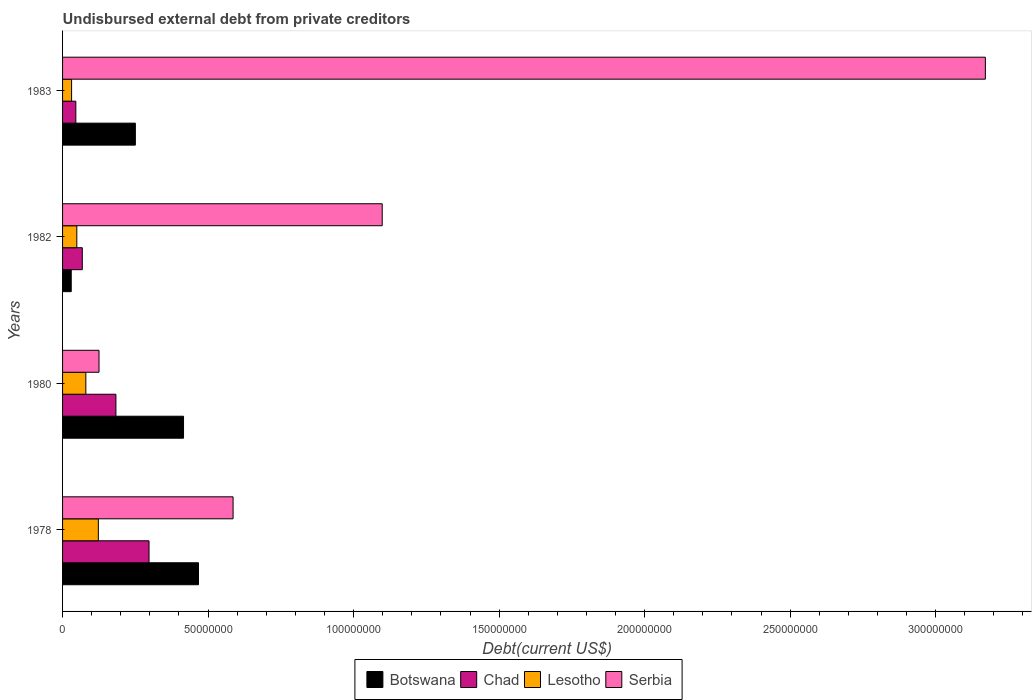How many different coloured bars are there?
Your response must be concise. 4. How many groups of bars are there?
Provide a short and direct response. 4. Are the number of bars on each tick of the Y-axis equal?
Offer a terse response. Yes. How many bars are there on the 3rd tick from the top?
Ensure brevity in your answer.  4. How many bars are there on the 4th tick from the bottom?
Offer a very short reply. 4. What is the label of the 4th group of bars from the top?
Make the answer very short. 1978. What is the total debt in Botswana in 1983?
Make the answer very short. 2.50e+07. Across all years, what is the maximum total debt in Botswana?
Your response must be concise. 4.67e+07. Across all years, what is the minimum total debt in Botswana?
Provide a succinct answer. 2.98e+06. In which year was the total debt in Botswana maximum?
Provide a succinct answer. 1978. In which year was the total debt in Chad minimum?
Give a very brief answer. 1983. What is the total total debt in Botswana in the graph?
Provide a short and direct response. 1.16e+08. What is the difference between the total debt in Botswana in 1978 and that in 1980?
Keep it short and to the point. 5.14e+06. What is the difference between the total debt in Lesotho in 1980 and the total debt in Botswana in 1982?
Provide a succinct answer. 5.02e+06. What is the average total debt in Botswana per year?
Your answer should be compact. 2.91e+07. In the year 1983, what is the difference between the total debt in Lesotho and total debt in Botswana?
Your answer should be compact. -2.19e+07. What is the ratio of the total debt in Chad in 1978 to that in 1983?
Your response must be concise. 6.52. Is the total debt in Chad in 1980 less than that in 1982?
Make the answer very short. No. Is the difference between the total debt in Lesotho in 1978 and 1980 greater than the difference between the total debt in Botswana in 1978 and 1980?
Offer a very short reply. No. What is the difference between the highest and the second highest total debt in Chad?
Your answer should be compact. 1.14e+07. What is the difference between the highest and the lowest total debt in Serbia?
Make the answer very short. 3.05e+08. In how many years, is the total debt in Chad greater than the average total debt in Chad taken over all years?
Your response must be concise. 2. What does the 4th bar from the top in 1980 represents?
Your answer should be very brief. Botswana. What does the 2nd bar from the bottom in 1983 represents?
Your response must be concise. Chad. Are all the bars in the graph horizontal?
Offer a very short reply. Yes. Are the values on the major ticks of X-axis written in scientific E-notation?
Give a very brief answer. No. How are the legend labels stacked?
Provide a short and direct response. Horizontal. What is the title of the graph?
Offer a terse response. Undisbursed external debt from private creditors. Does "Barbados" appear as one of the legend labels in the graph?
Give a very brief answer. No. What is the label or title of the X-axis?
Your answer should be very brief. Debt(current US$). What is the Debt(current US$) in Botswana in 1978?
Your answer should be very brief. 4.67e+07. What is the Debt(current US$) of Chad in 1978?
Your answer should be very brief. 2.97e+07. What is the Debt(current US$) of Lesotho in 1978?
Give a very brief answer. 1.23e+07. What is the Debt(current US$) of Serbia in 1978?
Give a very brief answer. 5.86e+07. What is the Debt(current US$) in Botswana in 1980?
Keep it short and to the point. 4.16e+07. What is the Debt(current US$) of Chad in 1980?
Offer a terse response. 1.83e+07. What is the Debt(current US$) in Lesotho in 1980?
Provide a succinct answer. 8.00e+06. What is the Debt(current US$) in Serbia in 1980?
Make the answer very short. 1.25e+07. What is the Debt(current US$) of Botswana in 1982?
Offer a terse response. 2.98e+06. What is the Debt(current US$) of Chad in 1982?
Your answer should be compact. 6.78e+06. What is the Debt(current US$) in Lesotho in 1982?
Give a very brief answer. 4.89e+06. What is the Debt(current US$) of Serbia in 1982?
Your answer should be very brief. 1.10e+08. What is the Debt(current US$) of Botswana in 1983?
Provide a succinct answer. 2.50e+07. What is the Debt(current US$) of Chad in 1983?
Your response must be concise. 4.56e+06. What is the Debt(current US$) in Lesotho in 1983?
Provide a short and direct response. 3.10e+06. What is the Debt(current US$) in Serbia in 1983?
Make the answer very short. 3.17e+08. Across all years, what is the maximum Debt(current US$) of Botswana?
Keep it short and to the point. 4.67e+07. Across all years, what is the maximum Debt(current US$) in Chad?
Your answer should be compact. 2.97e+07. Across all years, what is the maximum Debt(current US$) in Lesotho?
Offer a very short reply. 1.23e+07. Across all years, what is the maximum Debt(current US$) of Serbia?
Offer a terse response. 3.17e+08. Across all years, what is the minimum Debt(current US$) in Botswana?
Keep it short and to the point. 2.98e+06. Across all years, what is the minimum Debt(current US$) in Chad?
Your response must be concise. 4.56e+06. Across all years, what is the minimum Debt(current US$) in Lesotho?
Keep it short and to the point. 3.10e+06. Across all years, what is the minimum Debt(current US$) in Serbia?
Your answer should be compact. 1.25e+07. What is the total Debt(current US$) in Botswana in the graph?
Your response must be concise. 1.16e+08. What is the total Debt(current US$) of Chad in the graph?
Your answer should be very brief. 5.94e+07. What is the total Debt(current US$) in Lesotho in the graph?
Your answer should be very brief. 2.83e+07. What is the total Debt(current US$) of Serbia in the graph?
Provide a short and direct response. 4.98e+08. What is the difference between the Debt(current US$) of Botswana in 1978 and that in 1980?
Your answer should be very brief. 5.14e+06. What is the difference between the Debt(current US$) in Chad in 1978 and that in 1980?
Offer a very short reply. 1.14e+07. What is the difference between the Debt(current US$) of Lesotho in 1978 and that in 1980?
Make the answer very short. 4.29e+06. What is the difference between the Debt(current US$) in Serbia in 1978 and that in 1980?
Provide a short and direct response. 4.61e+07. What is the difference between the Debt(current US$) of Botswana in 1978 and that in 1982?
Offer a very short reply. 4.37e+07. What is the difference between the Debt(current US$) in Chad in 1978 and that in 1982?
Your answer should be very brief. 2.29e+07. What is the difference between the Debt(current US$) in Lesotho in 1978 and that in 1982?
Your answer should be compact. 7.40e+06. What is the difference between the Debt(current US$) of Serbia in 1978 and that in 1982?
Make the answer very short. -5.12e+07. What is the difference between the Debt(current US$) of Botswana in 1978 and that in 1983?
Offer a very short reply. 2.17e+07. What is the difference between the Debt(current US$) in Chad in 1978 and that in 1983?
Your response must be concise. 2.52e+07. What is the difference between the Debt(current US$) in Lesotho in 1978 and that in 1983?
Provide a succinct answer. 9.19e+06. What is the difference between the Debt(current US$) in Serbia in 1978 and that in 1983?
Give a very brief answer. -2.58e+08. What is the difference between the Debt(current US$) of Botswana in 1980 and that in 1982?
Your answer should be compact. 3.86e+07. What is the difference between the Debt(current US$) of Chad in 1980 and that in 1982?
Provide a succinct answer. 1.16e+07. What is the difference between the Debt(current US$) in Lesotho in 1980 and that in 1982?
Provide a short and direct response. 3.11e+06. What is the difference between the Debt(current US$) of Serbia in 1980 and that in 1982?
Provide a succinct answer. -9.73e+07. What is the difference between the Debt(current US$) in Botswana in 1980 and that in 1983?
Offer a terse response. 1.66e+07. What is the difference between the Debt(current US$) of Chad in 1980 and that in 1983?
Ensure brevity in your answer.  1.38e+07. What is the difference between the Debt(current US$) of Lesotho in 1980 and that in 1983?
Provide a succinct answer. 4.90e+06. What is the difference between the Debt(current US$) of Serbia in 1980 and that in 1983?
Offer a very short reply. -3.05e+08. What is the difference between the Debt(current US$) of Botswana in 1982 and that in 1983?
Offer a terse response. -2.20e+07. What is the difference between the Debt(current US$) of Chad in 1982 and that in 1983?
Your answer should be compact. 2.22e+06. What is the difference between the Debt(current US$) in Lesotho in 1982 and that in 1983?
Make the answer very short. 1.79e+06. What is the difference between the Debt(current US$) of Serbia in 1982 and that in 1983?
Your answer should be very brief. -2.07e+08. What is the difference between the Debt(current US$) of Botswana in 1978 and the Debt(current US$) of Chad in 1980?
Offer a terse response. 2.84e+07. What is the difference between the Debt(current US$) of Botswana in 1978 and the Debt(current US$) of Lesotho in 1980?
Keep it short and to the point. 3.87e+07. What is the difference between the Debt(current US$) of Botswana in 1978 and the Debt(current US$) of Serbia in 1980?
Offer a very short reply. 3.42e+07. What is the difference between the Debt(current US$) of Chad in 1978 and the Debt(current US$) of Lesotho in 1980?
Make the answer very short. 2.17e+07. What is the difference between the Debt(current US$) of Chad in 1978 and the Debt(current US$) of Serbia in 1980?
Ensure brevity in your answer.  1.72e+07. What is the difference between the Debt(current US$) in Lesotho in 1978 and the Debt(current US$) in Serbia in 1980?
Provide a succinct answer. -2.31e+05. What is the difference between the Debt(current US$) in Botswana in 1978 and the Debt(current US$) in Chad in 1982?
Your answer should be compact. 3.99e+07. What is the difference between the Debt(current US$) in Botswana in 1978 and the Debt(current US$) in Lesotho in 1982?
Ensure brevity in your answer.  4.18e+07. What is the difference between the Debt(current US$) of Botswana in 1978 and the Debt(current US$) of Serbia in 1982?
Offer a terse response. -6.31e+07. What is the difference between the Debt(current US$) in Chad in 1978 and the Debt(current US$) in Lesotho in 1982?
Ensure brevity in your answer.  2.48e+07. What is the difference between the Debt(current US$) in Chad in 1978 and the Debt(current US$) in Serbia in 1982?
Provide a short and direct response. -8.01e+07. What is the difference between the Debt(current US$) in Lesotho in 1978 and the Debt(current US$) in Serbia in 1982?
Your answer should be compact. -9.75e+07. What is the difference between the Debt(current US$) of Botswana in 1978 and the Debt(current US$) of Chad in 1983?
Provide a succinct answer. 4.21e+07. What is the difference between the Debt(current US$) in Botswana in 1978 and the Debt(current US$) in Lesotho in 1983?
Provide a succinct answer. 4.36e+07. What is the difference between the Debt(current US$) in Botswana in 1978 and the Debt(current US$) in Serbia in 1983?
Offer a very short reply. -2.70e+08. What is the difference between the Debt(current US$) of Chad in 1978 and the Debt(current US$) of Lesotho in 1983?
Offer a terse response. 2.66e+07. What is the difference between the Debt(current US$) of Chad in 1978 and the Debt(current US$) of Serbia in 1983?
Make the answer very short. -2.87e+08. What is the difference between the Debt(current US$) in Lesotho in 1978 and the Debt(current US$) in Serbia in 1983?
Provide a short and direct response. -3.05e+08. What is the difference between the Debt(current US$) in Botswana in 1980 and the Debt(current US$) in Chad in 1982?
Your answer should be compact. 3.48e+07. What is the difference between the Debt(current US$) in Botswana in 1980 and the Debt(current US$) in Lesotho in 1982?
Give a very brief answer. 3.67e+07. What is the difference between the Debt(current US$) in Botswana in 1980 and the Debt(current US$) in Serbia in 1982?
Ensure brevity in your answer.  -6.83e+07. What is the difference between the Debt(current US$) of Chad in 1980 and the Debt(current US$) of Lesotho in 1982?
Provide a short and direct response. 1.34e+07. What is the difference between the Debt(current US$) of Chad in 1980 and the Debt(current US$) of Serbia in 1982?
Ensure brevity in your answer.  -9.15e+07. What is the difference between the Debt(current US$) of Lesotho in 1980 and the Debt(current US$) of Serbia in 1982?
Your answer should be very brief. -1.02e+08. What is the difference between the Debt(current US$) in Botswana in 1980 and the Debt(current US$) in Chad in 1983?
Make the answer very short. 3.70e+07. What is the difference between the Debt(current US$) in Botswana in 1980 and the Debt(current US$) in Lesotho in 1983?
Your answer should be very brief. 3.85e+07. What is the difference between the Debt(current US$) of Botswana in 1980 and the Debt(current US$) of Serbia in 1983?
Keep it short and to the point. -2.76e+08. What is the difference between the Debt(current US$) in Chad in 1980 and the Debt(current US$) in Lesotho in 1983?
Offer a terse response. 1.52e+07. What is the difference between the Debt(current US$) of Chad in 1980 and the Debt(current US$) of Serbia in 1983?
Your answer should be very brief. -2.99e+08. What is the difference between the Debt(current US$) of Lesotho in 1980 and the Debt(current US$) of Serbia in 1983?
Your answer should be compact. -3.09e+08. What is the difference between the Debt(current US$) of Botswana in 1982 and the Debt(current US$) of Chad in 1983?
Offer a very short reply. -1.58e+06. What is the difference between the Debt(current US$) in Botswana in 1982 and the Debt(current US$) in Lesotho in 1983?
Ensure brevity in your answer.  -1.24e+05. What is the difference between the Debt(current US$) in Botswana in 1982 and the Debt(current US$) in Serbia in 1983?
Ensure brevity in your answer.  -3.14e+08. What is the difference between the Debt(current US$) in Chad in 1982 and the Debt(current US$) in Lesotho in 1983?
Your answer should be very brief. 3.68e+06. What is the difference between the Debt(current US$) in Chad in 1982 and the Debt(current US$) in Serbia in 1983?
Offer a very short reply. -3.10e+08. What is the difference between the Debt(current US$) in Lesotho in 1982 and the Debt(current US$) in Serbia in 1983?
Your response must be concise. -3.12e+08. What is the average Debt(current US$) of Botswana per year?
Ensure brevity in your answer.  2.91e+07. What is the average Debt(current US$) of Chad per year?
Offer a terse response. 1.48e+07. What is the average Debt(current US$) of Lesotho per year?
Your response must be concise. 7.07e+06. What is the average Debt(current US$) of Serbia per year?
Provide a succinct answer. 1.25e+08. In the year 1978, what is the difference between the Debt(current US$) of Botswana and Debt(current US$) of Chad?
Your answer should be very brief. 1.70e+07. In the year 1978, what is the difference between the Debt(current US$) in Botswana and Debt(current US$) in Lesotho?
Offer a very short reply. 3.44e+07. In the year 1978, what is the difference between the Debt(current US$) in Botswana and Debt(current US$) in Serbia?
Give a very brief answer. -1.19e+07. In the year 1978, what is the difference between the Debt(current US$) in Chad and Debt(current US$) in Lesotho?
Provide a short and direct response. 1.74e+07. In the year 1978, what is the difference between the Debt(current US$) in Chad and Debt(current US$) in Serbia?
Give a very brief answer. -2.89e+07. In the year 1978, what is the difference between the Debt(current US$) of Lesotho and Debt(current US$) of Serbia?
Provide a succinct answer. -4.63e+07. In the year 1980, what is the difference between the Debt(current US$) in Botswana and Debt(current US$) in Chad?
Your answer should be very brief. 2.32e+07. In the year 1980, what is the difference between the Debt(current US$) of Botswana and Debt(current US$) of Lesotho?
Offer a terse response. 3.36e+07. In the year 1980, what is the difference between the Debt(current US$) in Botswana and Debt(current US$) in Serbia?
Your answer should be compact. 2.90e+07. In the year 1980, what is the difference between the Debt(current US$) of Chad and Debt(current US$) of Lesotho?
Ensure brevity in your answer.  1.03e+07. In the year 1980, what is the difference between the Debt(current US$) in Chad and Debt(current US$) in Serbia?
Offer a very short reply. 5.81e+06. In the year 1980, what is the difference between the Debt(current US$) in Lesotho and Debt(current US$) in Serbia?
Provide a succinct answer. -4.52e+06. In the year 1982, what is the difference between the Debt(current US$) in Botswana and Debt(current US$) in Chad?
Offer a very short reply. -3.80e+06. In the year 1982, what is the difference between the Debt(current US$) of Botswana and Debt(current US$) of Lesotho?
Offer a terse response. -1.92e+06. In the year 1982, what is the difference between the Debt(current US$) in Botswana and Debt(current US$) in Serbia?
Offer a terse response. -1.07e+08. In the year 1982, what is the difference between the Debt(current US$) of Chad and Debt(current US$) of Lesotho?
Provide a succinct answer. 1.89e+06. In the year 1982, what is the difference between the Debt(current US$) in Chad and Debt(current US$) in Serbia?
Offer a very short reply. -1.03e+08. In the year 1982, what is the difference between the Debt(current US$) of Lesotho and Debt(current US$) of Serbia?
Your response must be concise. -1.05e+08. In the year 1983, what is the difference between the Debt(current US$) of Botswana and Debt(current US$) of Chad?
Keep it short and to the point. 2.05e+07. In the year 1983, what is the difference between the Debt(current US$) of Botswana and Debt(current US$) of Lesotho?
Provide a short and direct response. 2.19e+07. In the year 1983, what is the difference between the Debt(current US$) of Botswana and Debt(current US$) of Serbia?
Offer a very short reply. -2.92e+08. In the year 1983, what is the difference between the Debt(current US$) of Chad and Debt(current US$) of Lesotho?
Provide a succinct answer. 1.46e+06. In the year 1983, what is the difference between the Debt(current US$) of Chad and Debt(current US$) of Serbia?
Offer a terse response. -3.13e+08. In the year 1983, what is the difference between the Debt(current US$) of Lesotho and Debt(current US$) of Serbia?
Give a very brief answer. -3.14e+08. What is the ratio of the Debt(current US$) in Botswana in 1978 to that in 1980?
Your answer should be compact. 1.12. What is the ratio of the Debt(current US$) in Chad in 1978 to that in 1980?
Offer a very short reply. 1.62. What is the ratio of the Debt(current US$) of Lesotho in 1978 to that in 1980?
Offer a very short reply. 1.54. What is the ratio of the Debt(current US$) of Serbia in 1978 to that in 1980?
Your response must be concise. 4.68. What is the ratio of the Debt(current US$) in Botswana in 1978 to that in 1982?
Offer a very short reply. 15.69. What is the ratio of the Debt(current US$) in Chad in 1978 to that in 1982?
Your response must be concise. 4.38. What is the ratio of the Debt(current US$) of Lesotho in 1978 to that in 1982?
Offer a very short reply. 2.51. What is the ratio of the Debt(current US$) of Serbia in 1978 to that in 1982?
Ensure brevity in your answer.  0.53. What is the ratio of the Debt(current US$) in Botswana in 1978 to that in 1983?
Keep it short and to the point. 1.87. What is the ratio of the Debt(current US$) in Chad in 1978 to that in 1983?
Provide a succinct answer. 6.52. What is the ratio of the Debt(current US$) in Lesotho in 1978 to that in 1983?
Provide a succinct answer. 3.96. What is the ratio of the Debt(current US$) of Serbia in 1978 to that in 1983?
Your response must be concise. 0.18. What is the ratio of the Debt(current US$) of Botswana in 1980 to that in 1982?
Your response must be concise. 13.96. What is the ratio of the Debt(current US$) of Chad in 1980 to that in 1982?
Give a very brief answer. 2.7. What is the ratio of the Debt(current US$) of Lesotho in 1980 to that in 1982?
Provide a short and direct response. 1.64. What is the ratio of the Debt(current US$) in Serbia in 1980 to that in 1982?
Provide a succinct answer. 0.11. What is the ratio of the Debt(current US$) of Botswana in 1980 to that in 1983?
Your response must be concise. 1.66. What is the ratio of the Debt(current US$) of Chad in 1980 to that in 1983?
Your response must be concise. 4.02. What is the ratio of the Debt(current US$) in Lesotho in 1980 to that in 1983?
Offer a terse response. 2.58. What is the ratio of the Debt(current US$) in Serbia in 1980 to that in 1983?
Provide a short and direct response. 0.04. What is the ratio of the Debt(current US$) in Botswana in 1982 to that in 1983?
Provide a short and direct response. 0.12. What is the ratio of the Debt(current US$) in Chad in 1982 to that in 1983?
Give a very brief answer. 1.49. What is the ratio of the Debt(current US$) in Lesotho in 1982 to that in 1983?
Offer a terse response. 1.58. What is the ratio of the Debt(current US$) in Serbia in 1982 to that in 1983?
Give a very brief answer. 0.35. What is the difference between the highest and the second highest Debt(current US$) of Botswana?
Make the answer very short. 5.14e+06. What is the difference between the highest and the second highest Debt(current US$) of Chad?
Give a very brief answer. 1.14e+07. What is the difference between the highest and the second highest Debt(current US$) in Lesotho?
Offer a very short reply. 4.29e+06. What is the difference between the highest and the second highest Debt(current US$) in Serbia?
Provide a succinct answer. 2.07e+08. What is the difference between the highest and the lowest Debt(current US$) in Botswana?
Ensure brevity in your answer.  4.37e+07. What is the difference between the highest and the lowest Debt(current US$) of Chad?
Offer a very short reply. 2.52e+07. What is the difference between the highest and the lowest Debt(current US$) in Lesotho?
Provide a succinct answer. 9.19e+06. What is the difference between the highest and the lowest Debt(current US$) in Serbia?
Give a very brief answer. 3.05e+08. 